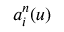Convert formula to latex. <formula><loc_0><loc_0><loc_500><loc_500>a _ { i } ^ { n } ( u )</formula> 